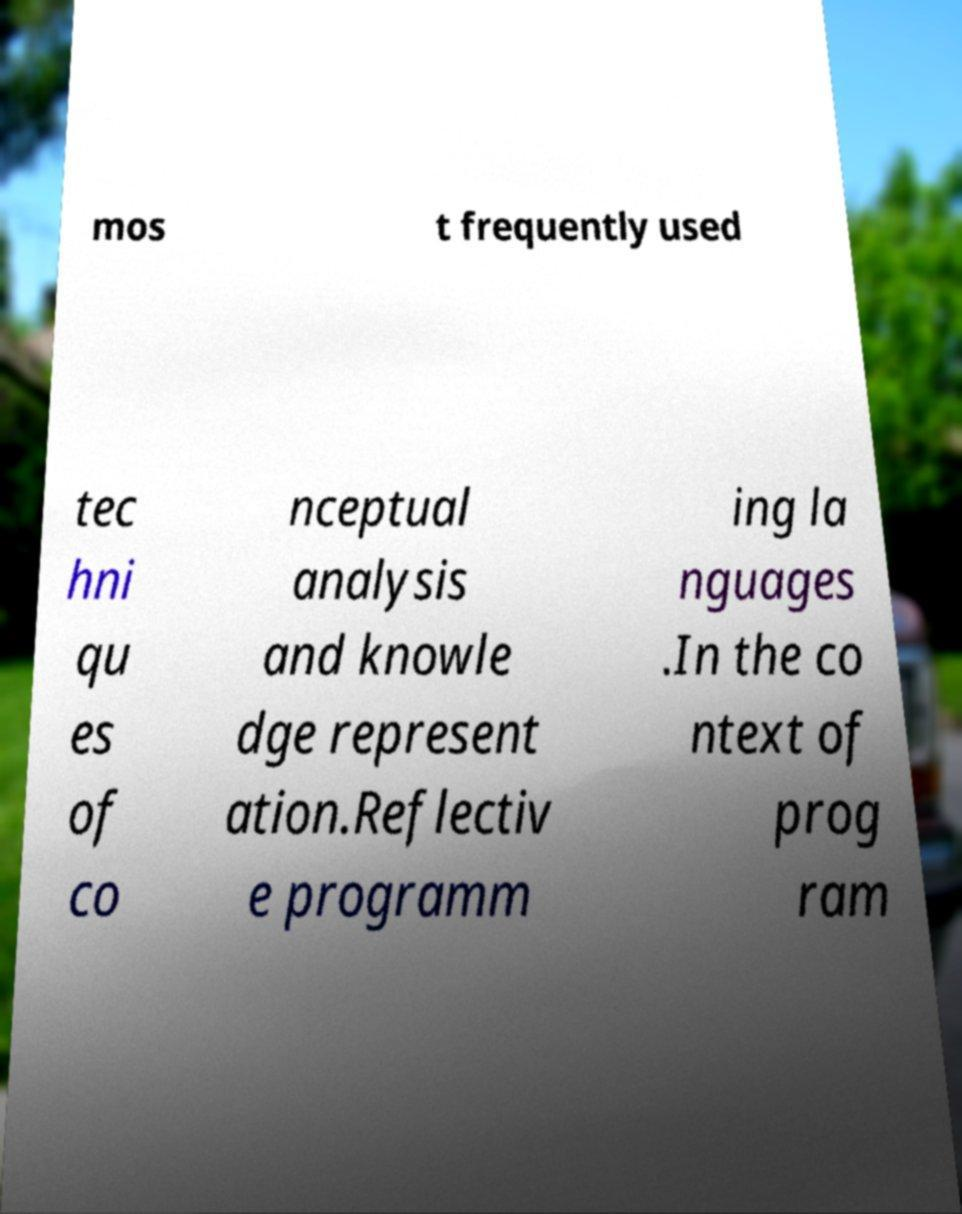Can you read and provide the text displayed in the image?This photo seems to have some interesting text. Can you extract and type it out for me? mos t frequently used tec hni qu es of co nceptual analysis and knowle dge represent ation.Reflectiv e programm ing la nguages .In the co ntext of prog ram 